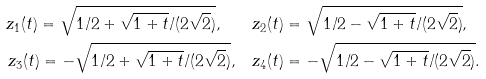Convert formula to latex. <formula><loc_0><loc_0><loc_500><loc_500>z _ { 1 } ( t ) = \sqrt { 1 / 2 + \sqrt { 1 + t } / ( 2 \sqrt { 2 } ) } , \quad & z _ { 2 } ( t ) = \sqrt { 1 / 2 - \sqrt { 1 + t } / ( 2 \sqrt { 2 } ) } , \\ z _ { 3 } ( t ) = - \sqrt { 1 / 2 + \sqrt { 1 + t } / ( 2 \sqrt { 2 } ) } , \quad & z _ { 4 } ( t ) = - \sqrt { 1 / 2 - \sqrt { 1 + t } / ( 2 \sqrt { 2 } ) } .</formula> 